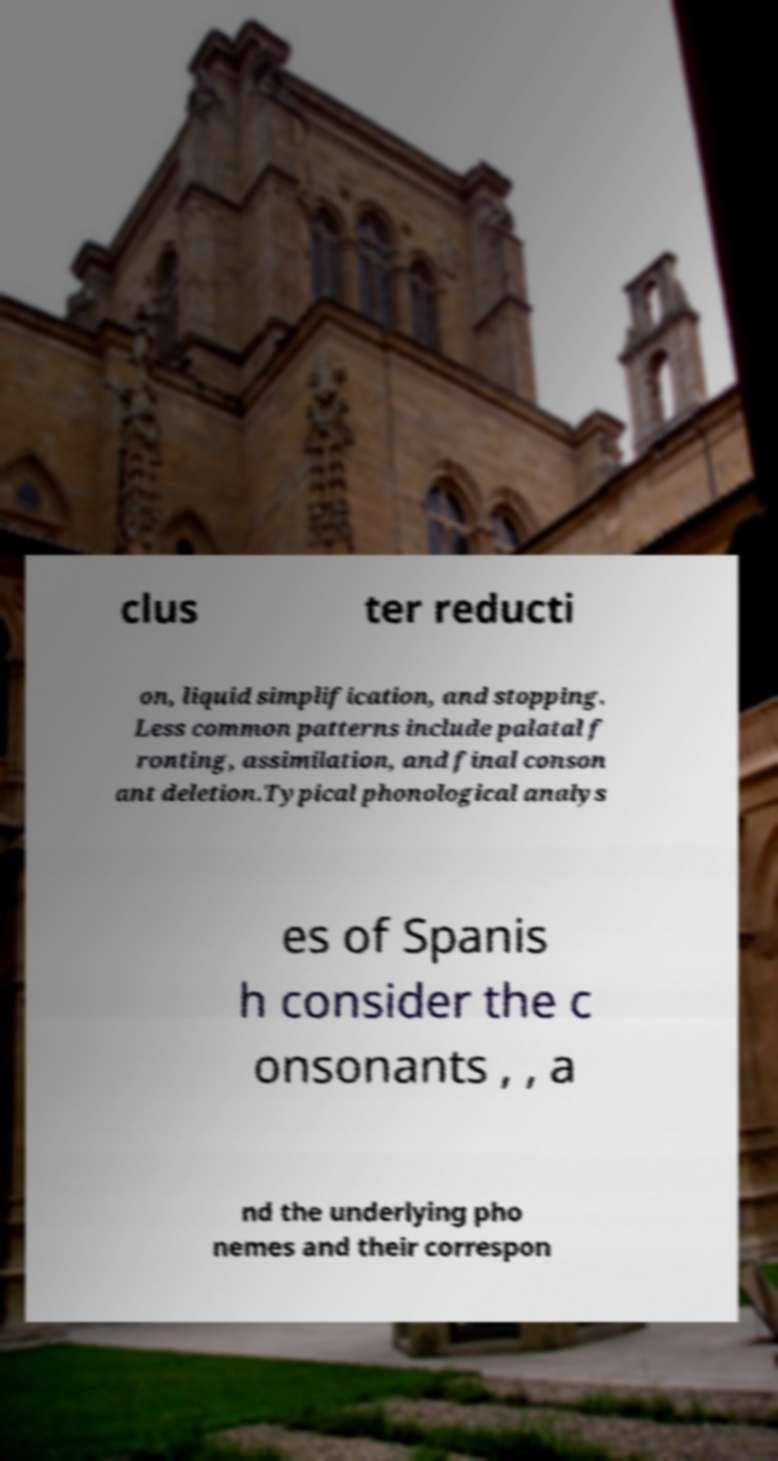What messages or text are displayed in this image? I need them in a readable, typed format. clus ter reducti on, liquid simplification, and stopping. Less common patterns include palatal f ronting, assimilation, and final conson ant deletion.Typical phonological analys es of Spanis h consider the c onsonants , , a nd the underlying pho nemes and their correspon 